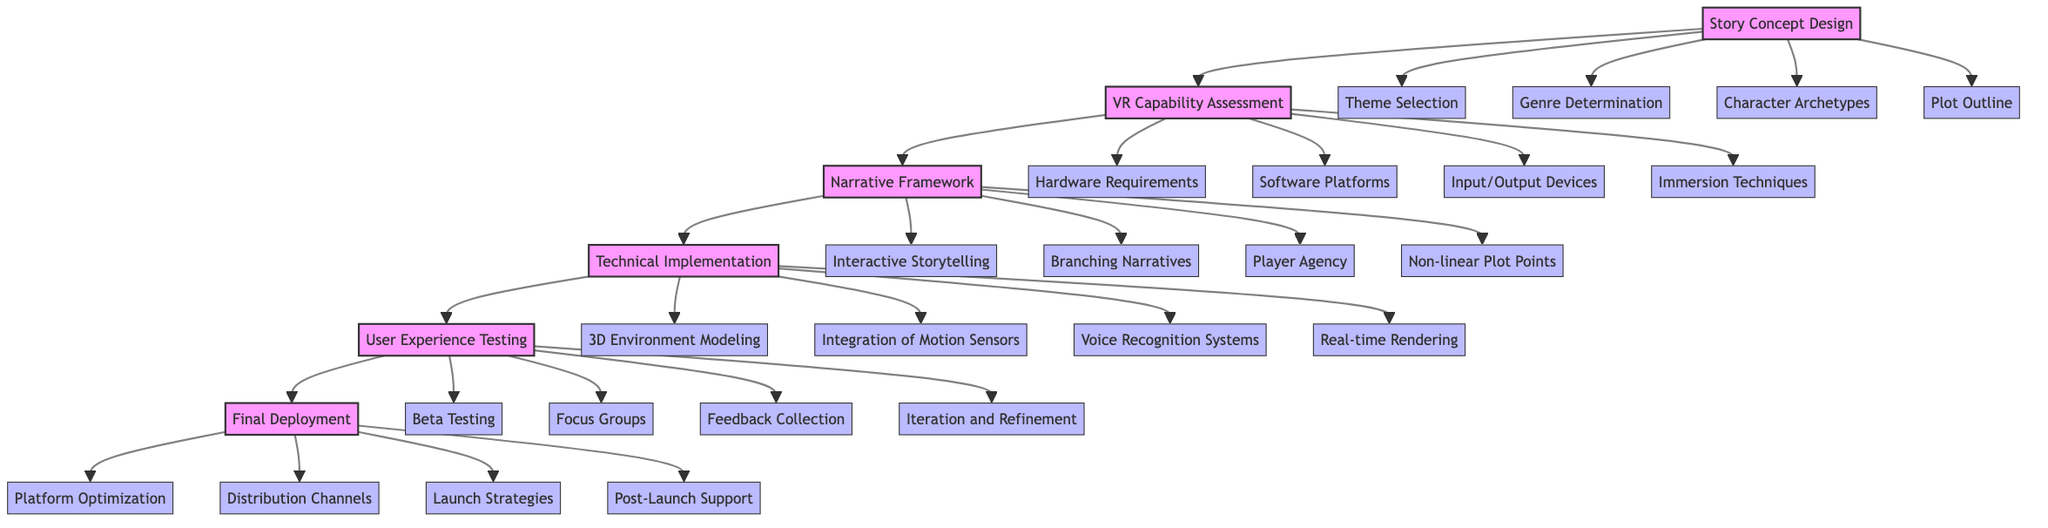What is the first block in the diagram? The first block in the diagram is labeled "Story Concept Design." This can be identified as the starting point of the flow in the block diagram.
Answer: Story Concept Design How many detailed elements are listed under "Technical Implementation"? Under the block "Technical Implementation," there are four detailed elements listed: "3D Environment Modeling," "Integration of Motion Sensors," "Voice Recognition Systems," and "Real-time Rendering." This total can be counted directly from the diagram.
Answer: 4 What block comes after "VR Capability Assessment"? The block that comes after "VR Capability Assessment" is "Narrative Framework." This sequence is determined by following the arrows that connect the blocks in the order presented.
Answer: Narrative Framework Which two blocks are connected by the arrow indicating the direction of flow? The two blocks connected by an arrow indicating the flow of the process are "User Experience Testing" and "Final Deployment." This can be visually traced through the arrows directing from one block to the next.
Answer: User Experience Testing and Final Deployment What are the last two elements in the sequence of blocks? The last two blocks in the sequence are "User Experience Testing" and "Final Deployment." This can be observed by looking at the final order of the blocks as they are laid out in the diagram from the start to the end.
Answer: User Experience Testing and Final Deployment How many blocks are present in the diagram? There are six distinct blocks in the diagram. This can be obtained by counting the labeled blocks that are interconnected, which include: "Story Concept Design," "VR Capability Assessment," "Narrative Framework," "Technical Implementation," "User Experience Testing," and "Final Deployment."
Answer: 6 What is the relationship between "Narrative Framework" and "Technical Implementation"? The relationship between "Narrative Framework" and "Technical Implementation" is that "Technical Implementation" follows directly after "Narrative Framework" in the flow of the process. This is indicated by the arrow connecting the two blocks, showing the progression from one stage to the next.
Answer: Technical Implementation follows after Narrative Framework Which stage involves feedback collection? The stage that involves feedback collection is "User Experience Testing." This is evident from the list of detailed elements under this block, which includes "Feedback Collection" as one of its components.
Answer: User Experience Testing What type of testing occurs in the "User Experience Testing" block? The type of testing that occurs in the "User Experience Testing" block includes "Beta Testing" and "Focus Groups." This information can be extracted from the details listed within that specific block, where these testing methods are noted.
Answer: Beta Testing and Focus Groups 